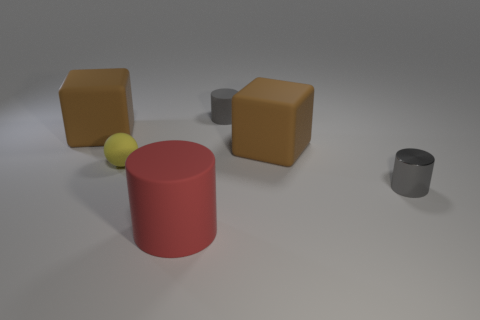Subtract all big red cylinders. How many cylinders are left? 2 Subtract 2 cylinders. How many cylinders are left? 1 Add 3 red rubber things. How many objects exist? 9 Subtract all cubes. How many objects are left? 4 Subtract all brown cubes. How many red cylinders are left? 1 Subtract all small spheres. Subtract all big matte cylinders. How many objects are left? 4 Add 4 yellow balls. How many yellow balls are left? 5 Add 2 matte objects. How many matte objects exist? 7 Subtract all gray cylinders. How many cylinders are left? 1 Subtract 0 blue spheres. How many objects are left? 6 